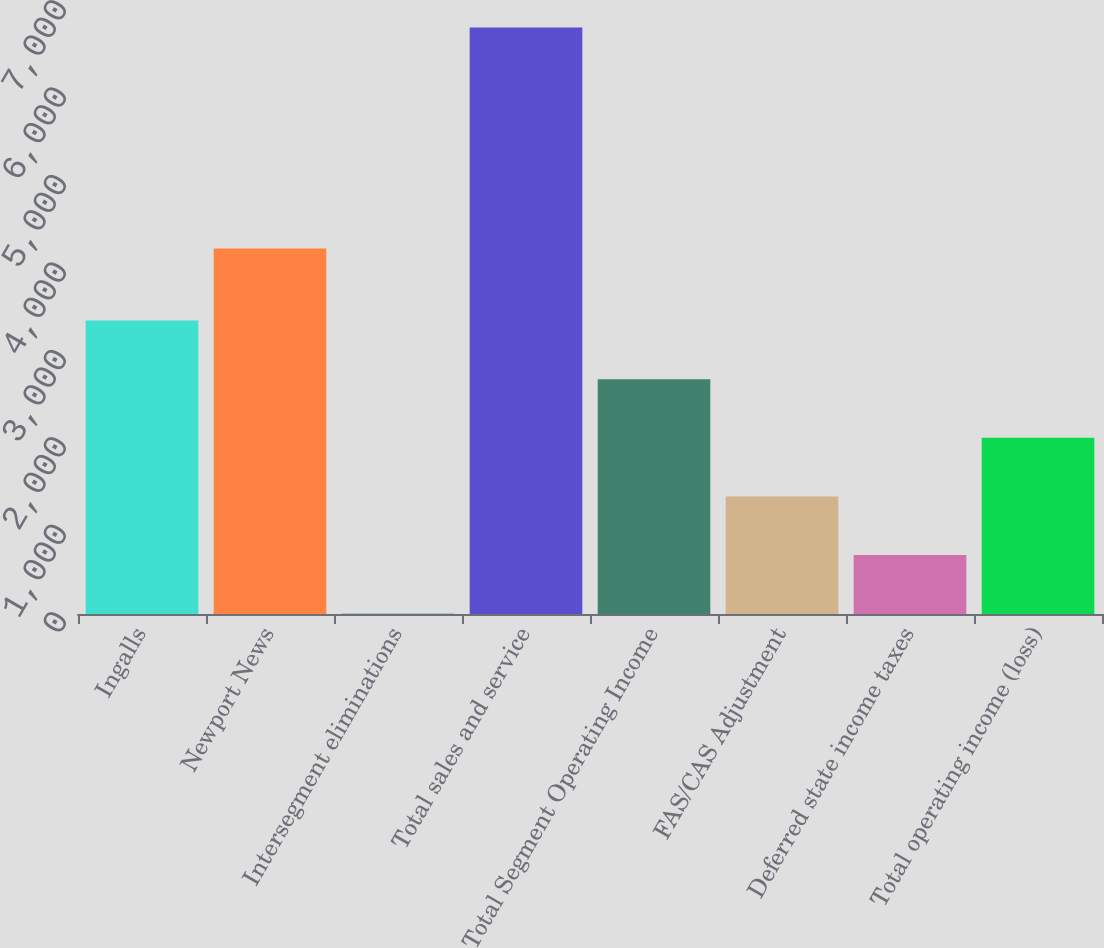<chart> <loc_0><loc_0><loc_500><loc_500><bar_chart><fcel>Ingalls<fcel>Newport News<fcel>Intersegment eliminations<fcel>Total sales and service<fcel>Total Segment Operating Income<fcel>FAS/CAS Adjustment<fcel>Deferred state income taxes<fcel>Total operating income (loss)<nl><fcel>3356<fcel>4180<fcel>4<fcel>6708<fcel>2685.6<fcel>1344.8<fcel>674.4<fcel>2015.2<nl></chart> 